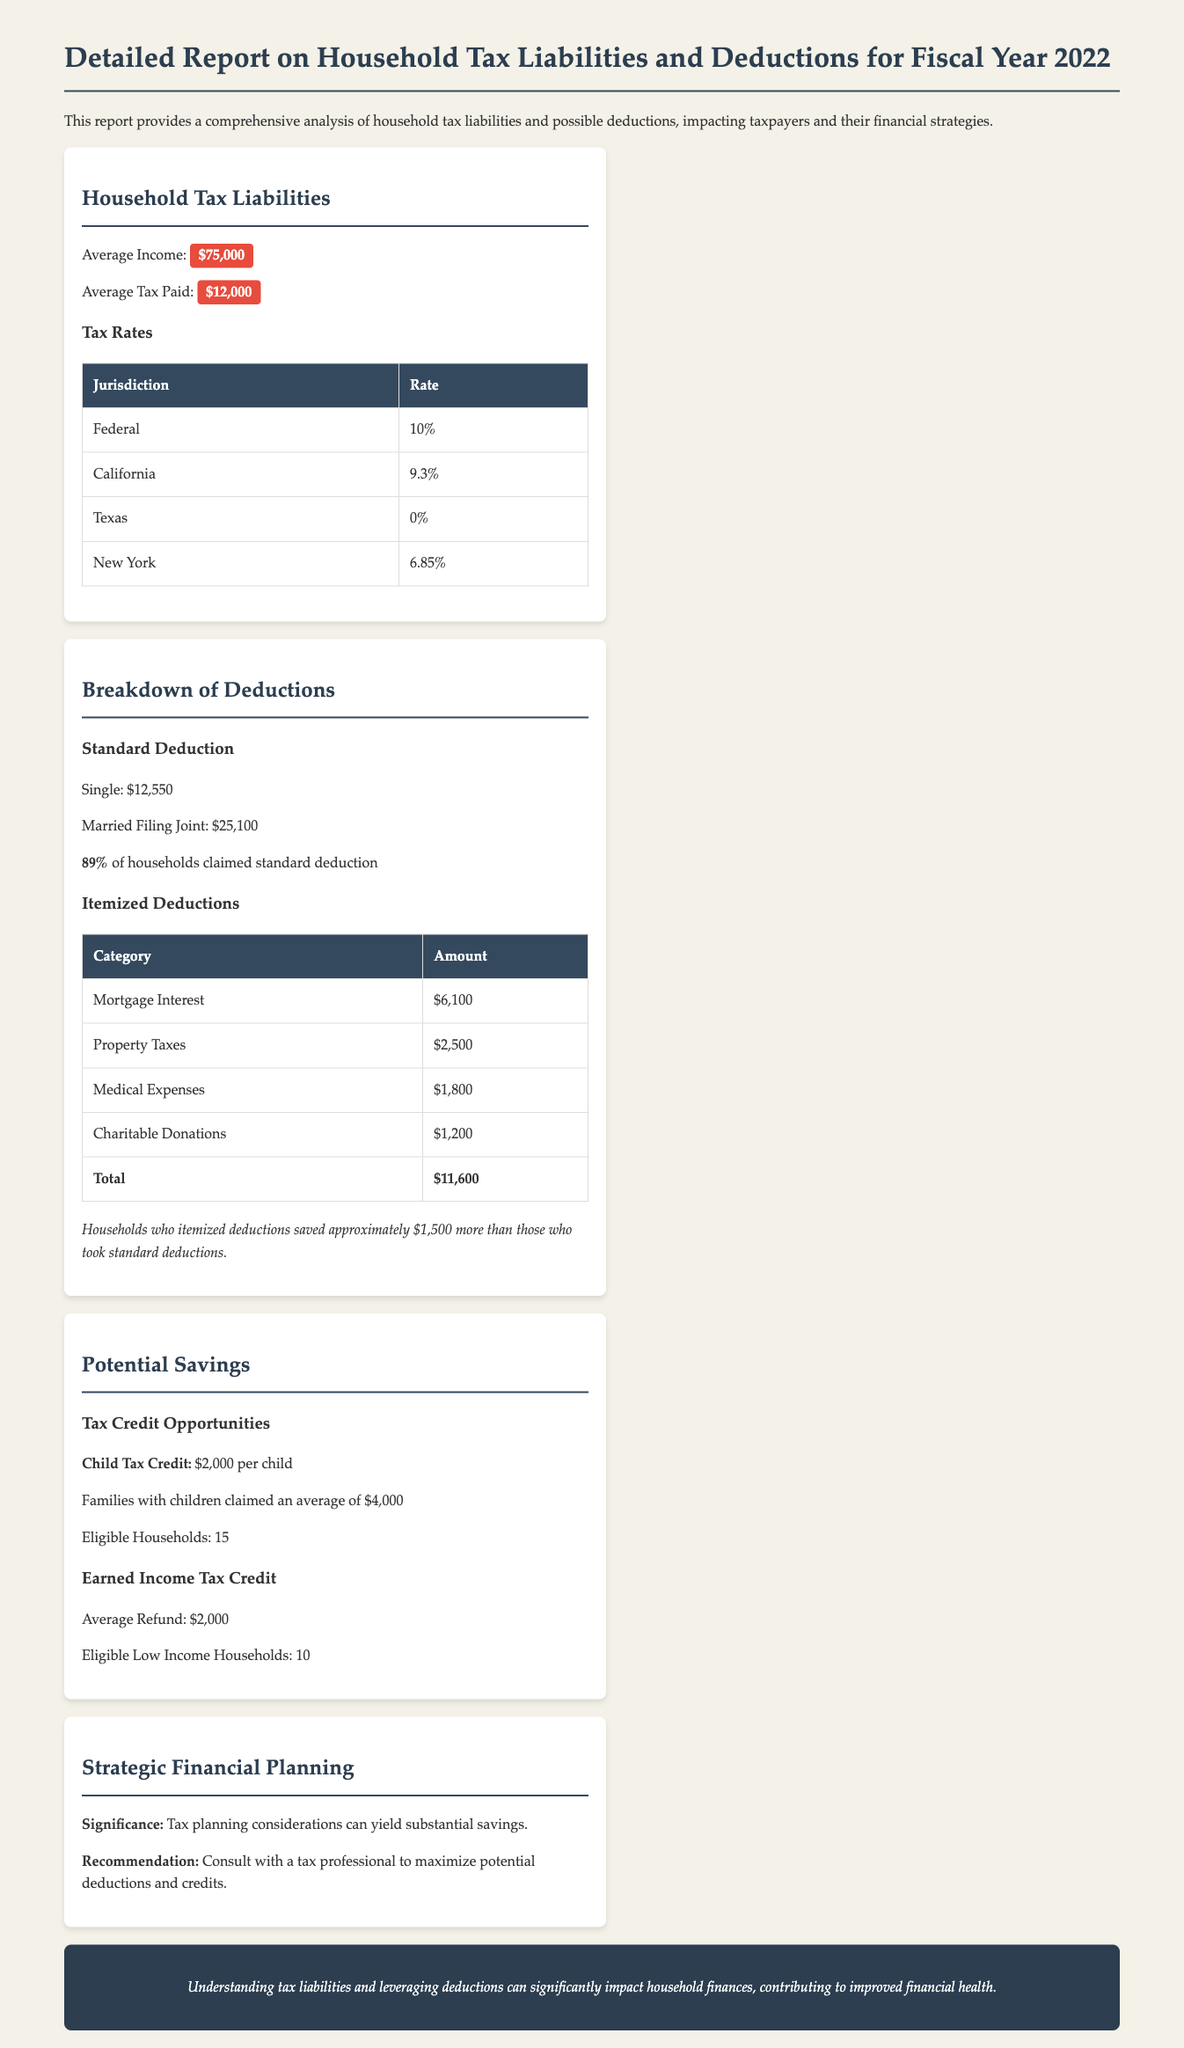What was the average income? The average income is mentioned in the document as $75,000.
Answer: $75,000 How much was the average tax paid? The average tax paid is noted as $12,000 in the report.
Answer: $12,000 What is the standard deduction for married filing jointly? The document specifies the standard deduction for married filing jointly as $25,100.
Answer: $25,100 What is the total amount of itemized deductions? The total amount of itemized deductions is detailed in the table as $11,600.
Answer: $11,600 How many eligible households claimed the Child Tax Credit? The report indicates that 15 households were eligible for the Child Tax Credit.
Answer: 15 What savings did itemizing deductions provide compared to standard deductions? It is mentioned that households who itemized deductions saved approximately $1,500 more.
Answer: $1,500 What is the average refund for the Earned Income Tax Credit? The average refund for the Earned Income Tax Credit is stated as $2,000.
Answer: $2,000 What is the significance of tax planning according to the report? The document highlights that tax planning can yield substantial savings.
Answer: Substantial savings What is the recommended action in strategic financial planning? The recommendation in the report is to consult with a tax professional.
Answer: Consult with a tax professional 